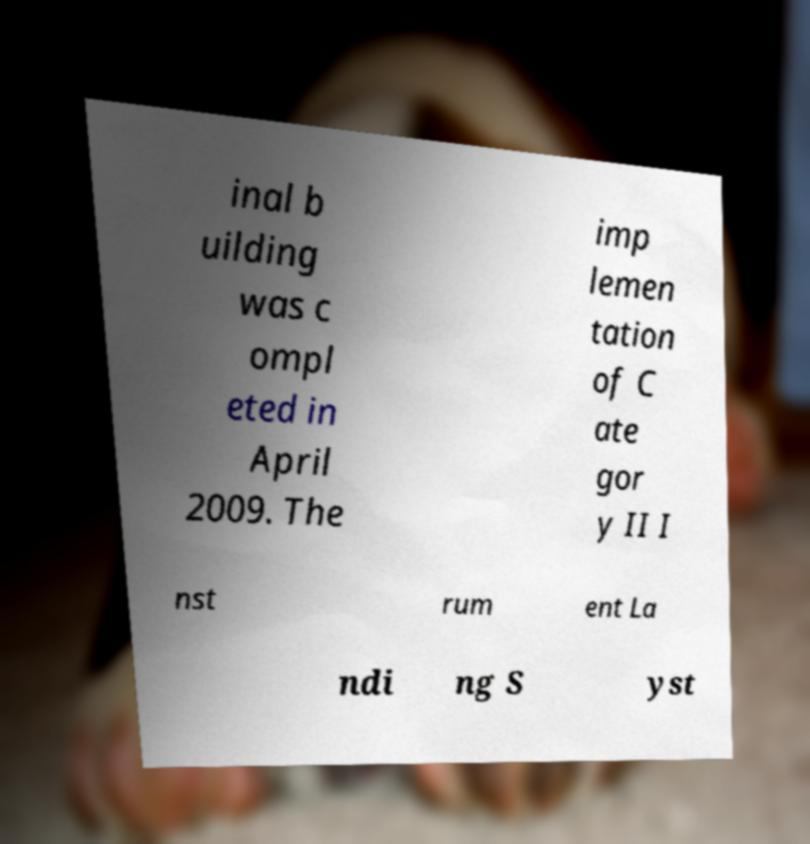Please identify and transcribe the text found in this image. inal b uilding was c ompl eted in April 2009. The imp lemen tation of C ate gor y II I nst rum ent La ndi ng S yst 